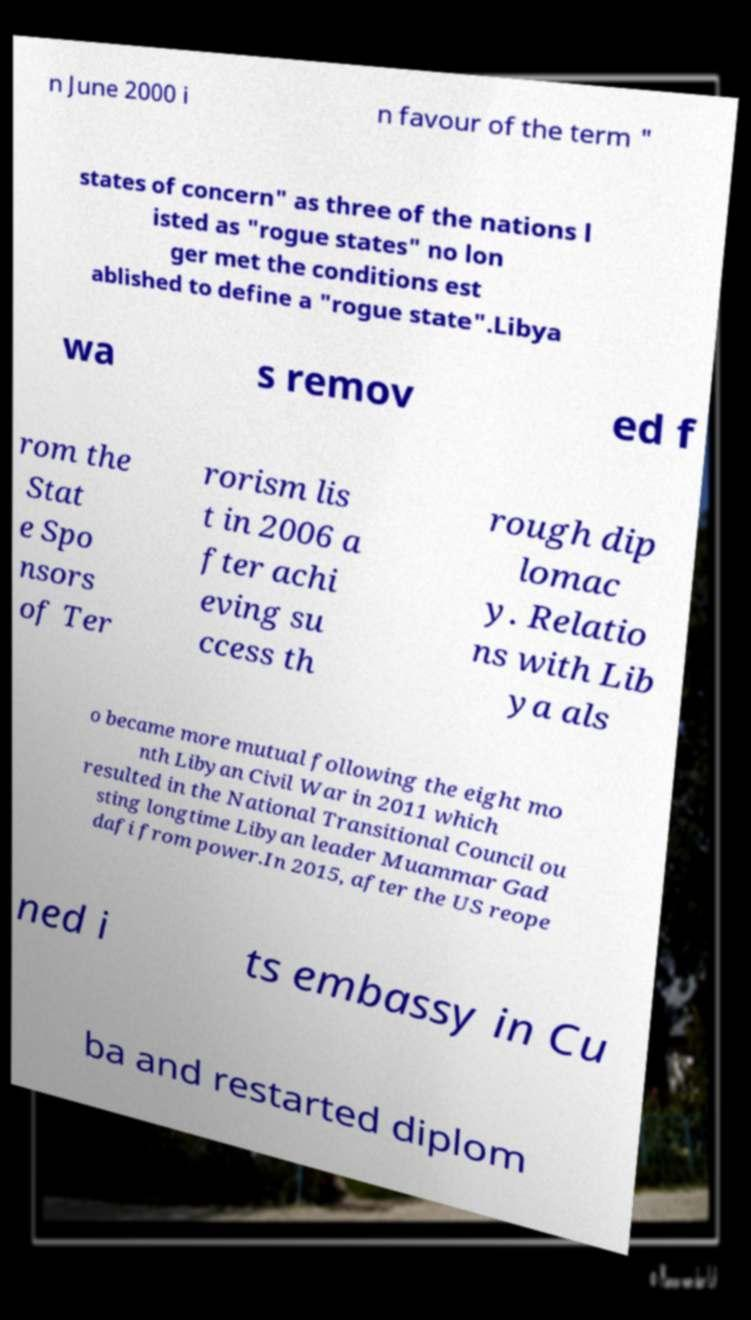Could you extract and type out the text from this image? n June 2000 i n favour of the term " states of concern" as three of the nations l isted as "rogue states" no lon ger met the conditions est ablished to define a "rogue state".Libya wa s remov ed f rom the Stat e Spo nsors of Ter rorism lis t in 2006 a fter achi eving su ccess th rough dip lomac y. Relatio ns with Lib ya als o became more mutual following the eight mo nth Libyan Civil War in 2011 which resulted in the National Transitional Council ou sting longtime Libyan leader Muammar Gad dafi from power.In 2015, after the US reope ned i ts embassy in Cu ba and restarted diplom 